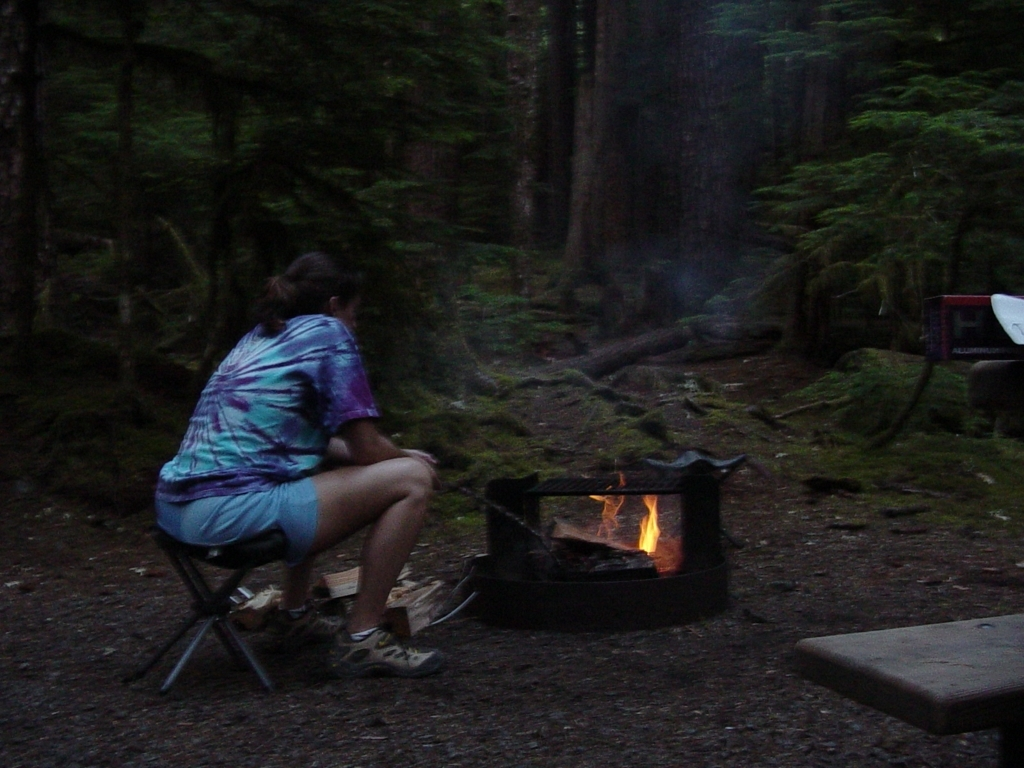Are there any specific elements in the image that indicate the time of day or season? The dim lighting and the active firepit imply that the image was captured during the evening or at dusk. The presence of lush green trees suggests it might be late spring to summer when the forest is full of life, and outdoor activities such as camping are popular. 